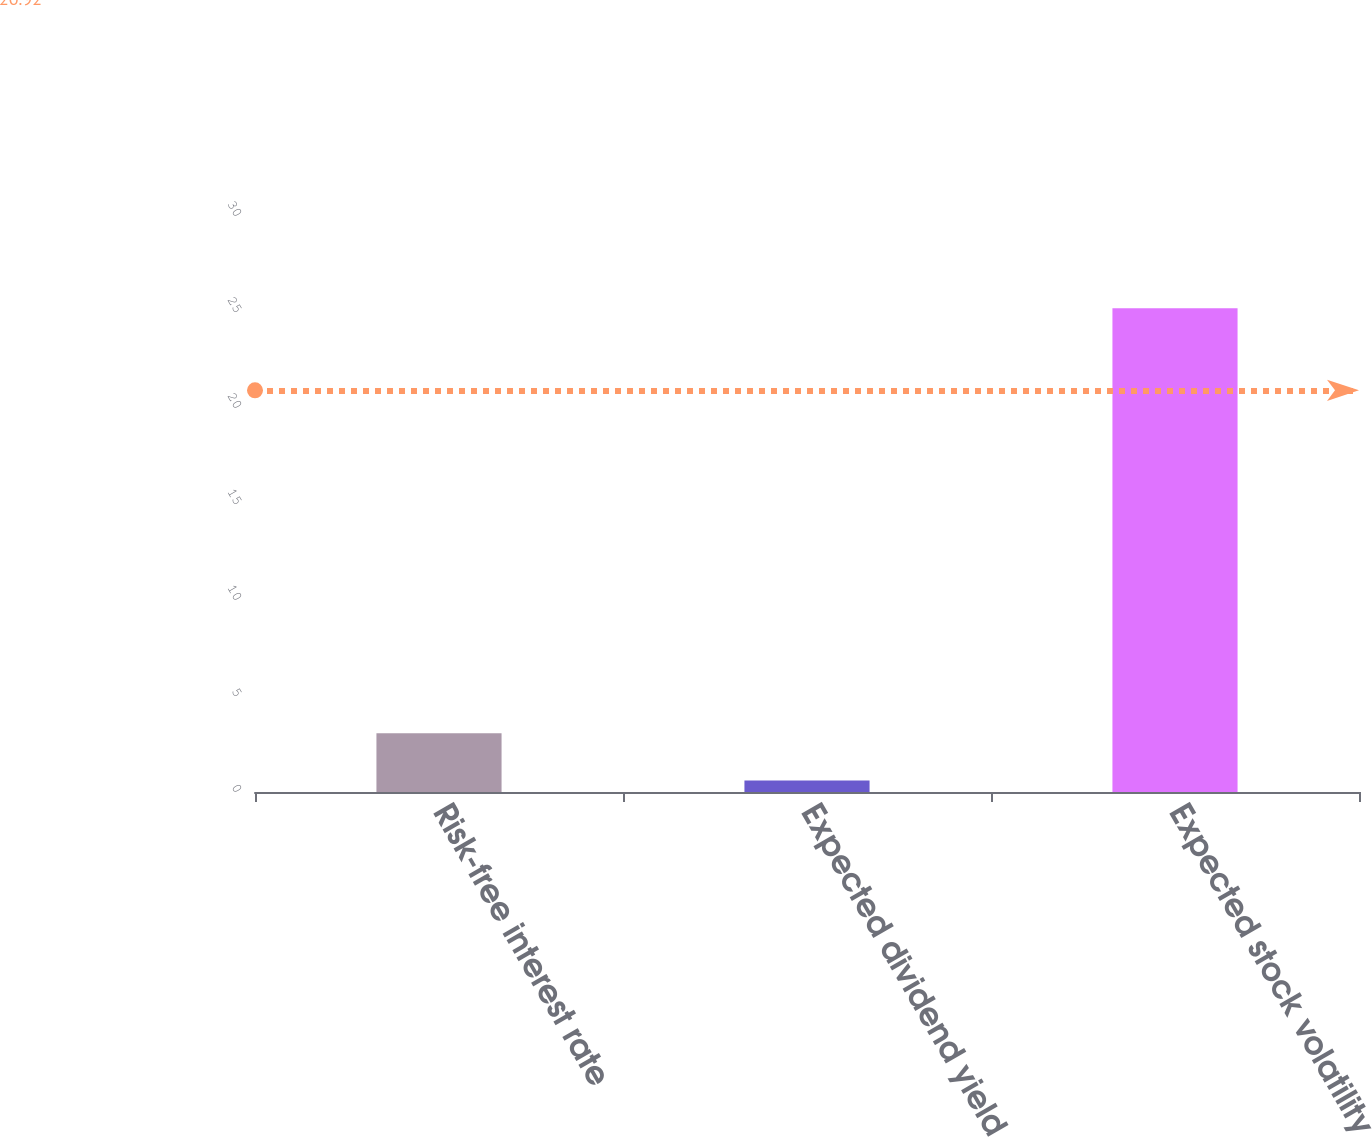Convert chart. <chart><loc_0><loc_0><loc_500><loc_500><bar_chart><fcel>Risk-free interest rate<fcel>Expected dividend yield<fcel>Expected stock volatility<nl><fcel>3.06<fcel>0.6<fcel>25.2<nl></chart> 